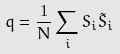<formula> <loc_0><loc_0><loc_500><loc_500>q = \frac { 1 } { N } \sum _ { i } S _ { i } \tilde { S } _ { i }</formula> 